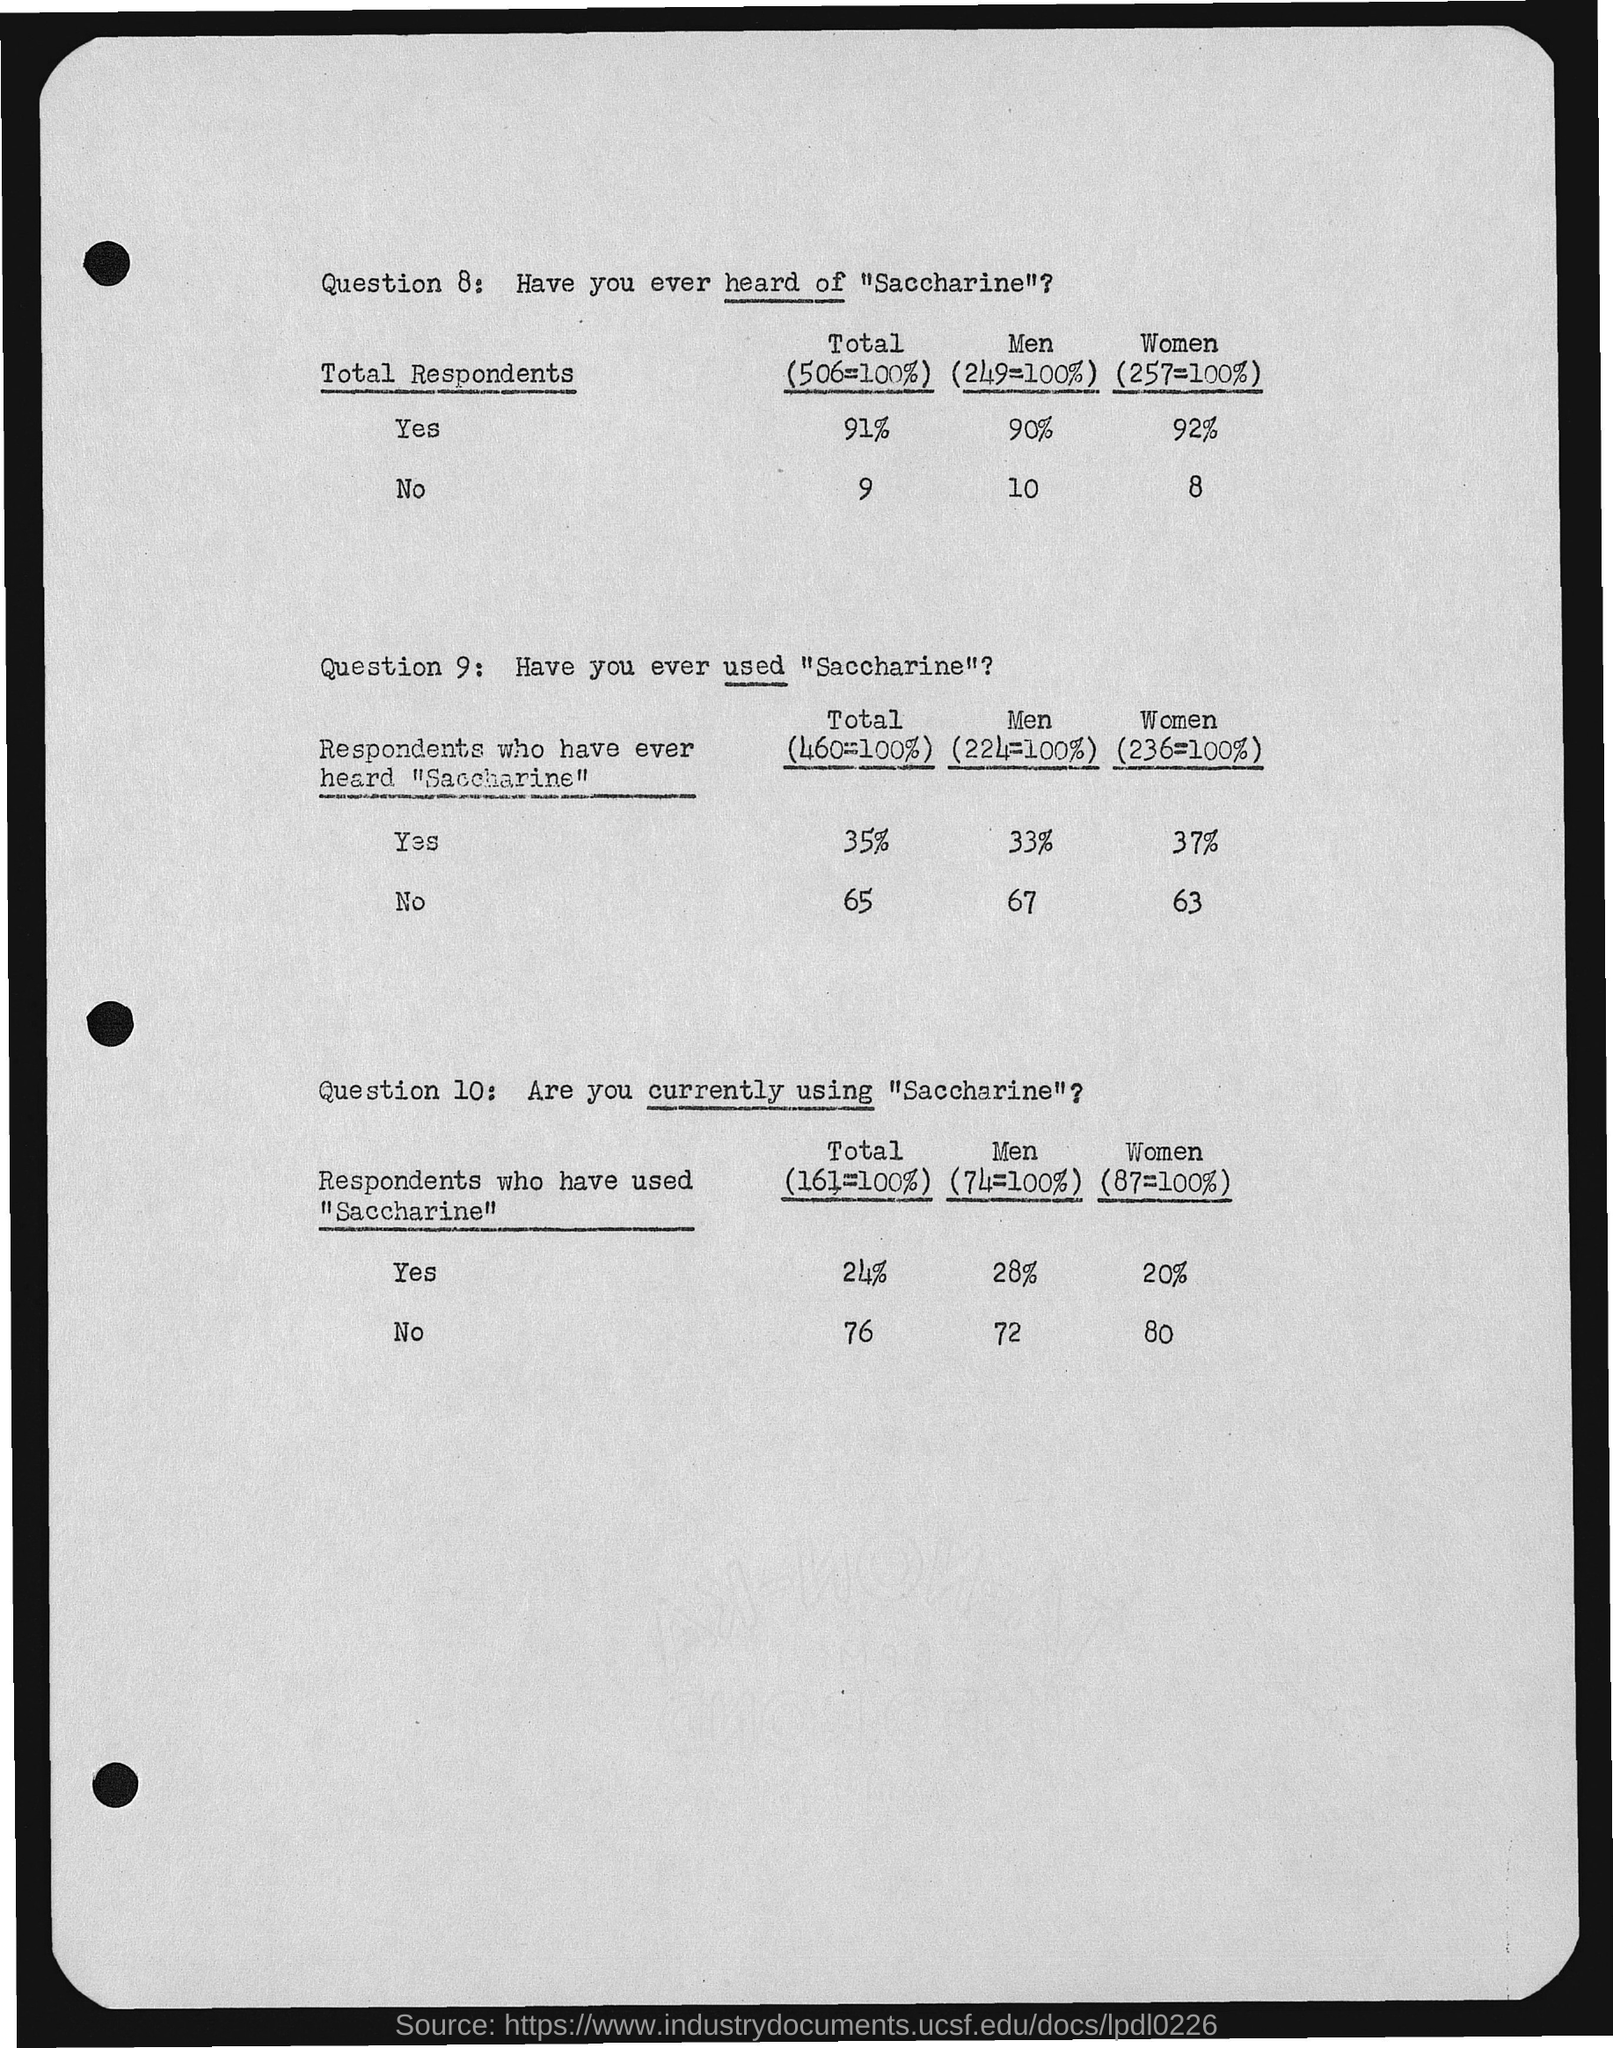Point out several critical features in this image. The total number of respondents who answered 'No' is 100%. Out of the 100% of men who responded, 90% said yes. Out of the 100% of women surveyed, 8% said no. A total of 506 people, or 100%, said yes. Out of those, 91 people responded. A majority of the women, 92%, responded with a yes. 